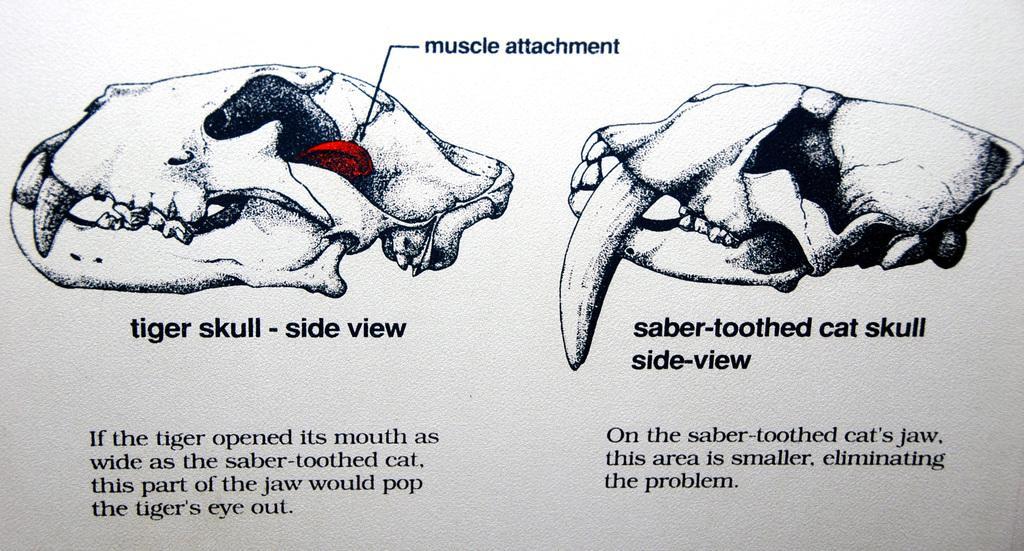Describe this image in one or two sentences. In this image we can see the pictures of skulls on the paper and some text at the bottom. 